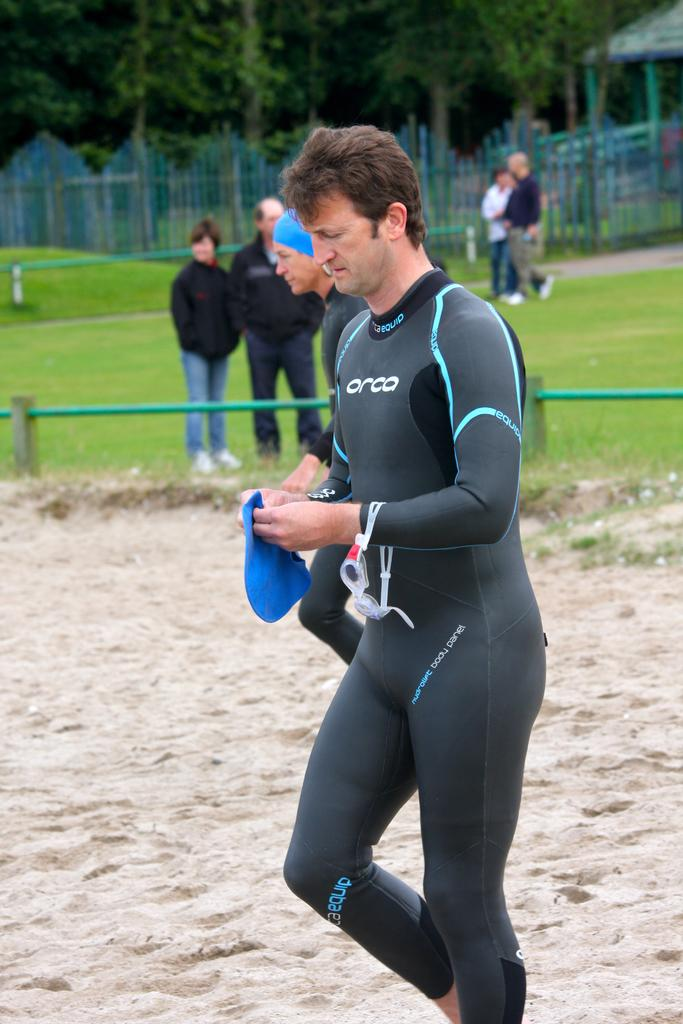Who is the main subject in the image? There is a man in the center of the image. What is the man doing in the image? The man is walking. What is the man holding in the image? The man is holding an object. What can be seen in the background of the image? There are people, a fence, and trees in the background of the image. What structure is located on the right side of the image? There is a shed on the right side of the image. What type of brush is the man using to paint the committee in the image? There is no brush, committee, or painting activity present in the image. 